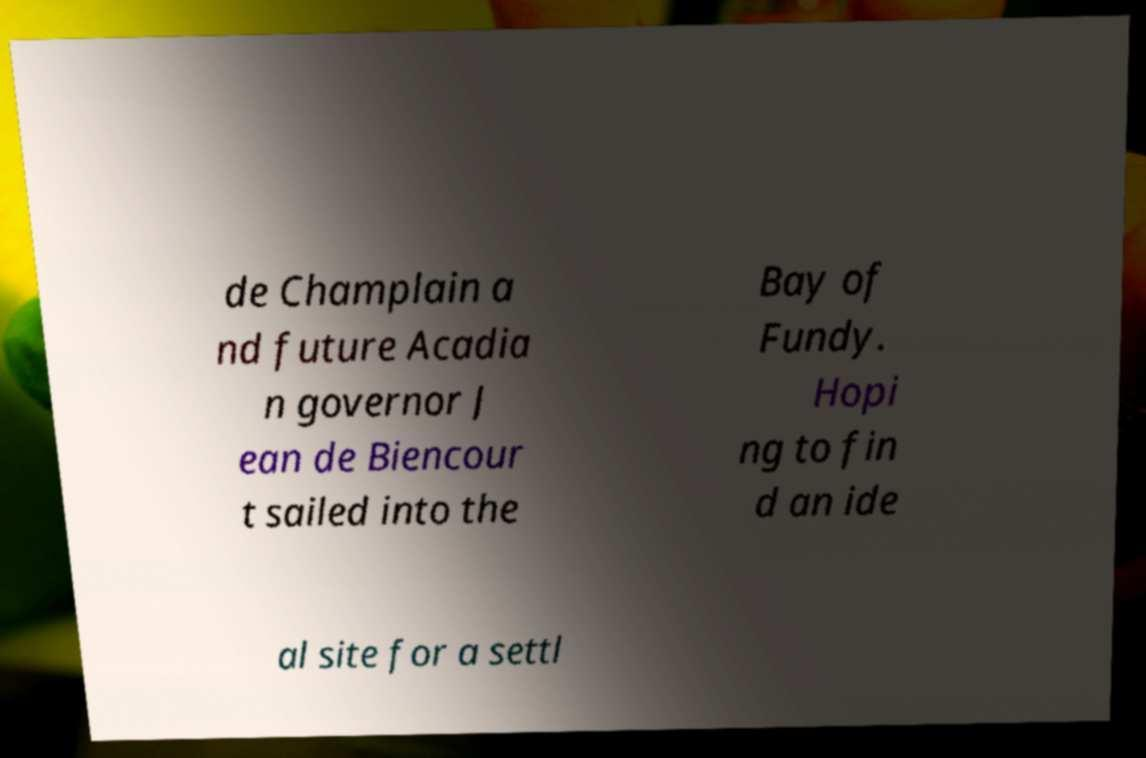Can you read and provide the text displayed in the image?This photo seems to have some interesting text. Can you extract and type it out for me? de Champlain a nd future Acadia n governor J ean de Biencour t sailed into the Bay of Fundy. Hopi ng to fin d an ide al site for a settl 